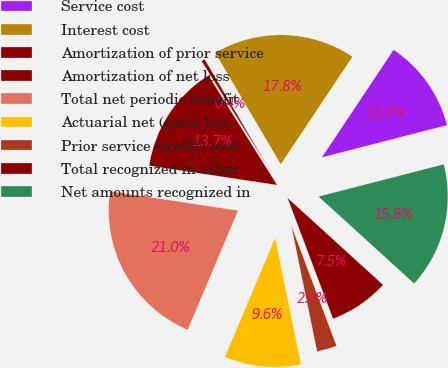Convert chart to OTSL. <chart><loc_0><loc_0><loc_500><loc_500><pie_chart><fcel>Service cost<fcel>Interest cost<fcel>Amortization of prior service<fcel>Amortization of net loss<fcel>Total net periodic benefit<fcel>Actuarial net (gain) loss<fcel>Prior service (credit) cost<fcel>Total recognized in other<fcel>Net amounts recognized in<nl><fcel>11.64%<fcel>17.82%<fcel>0.45%<fcel>13.7%<fcel>21.03%<fcel>9.58%<fcel>2.51%<fcel>7.52%<fcel>15.76%<nl></chart> 